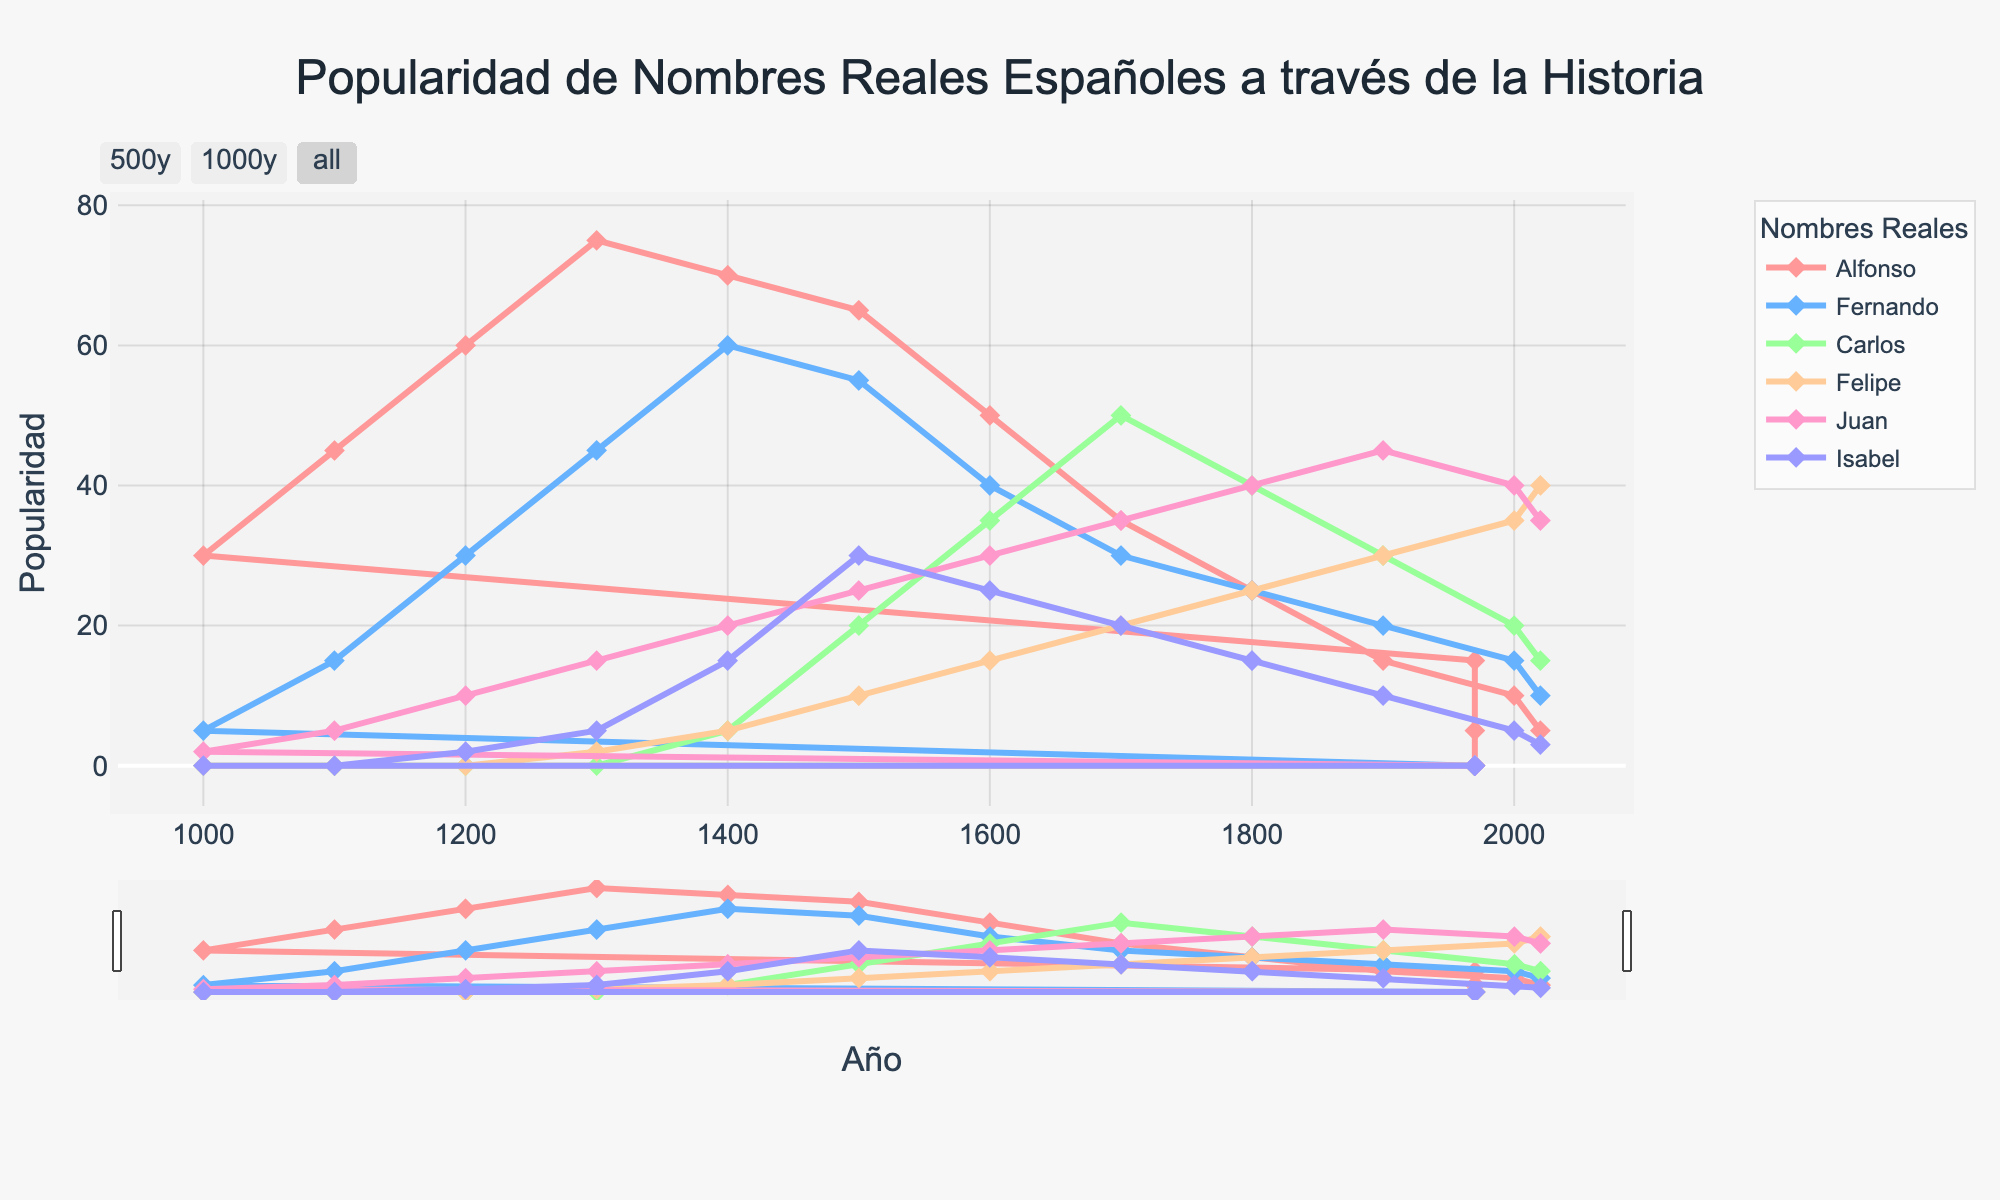Which name has the highest popularity in the year 1300? To determine this, we look at the data points for each name in the year 1300. Alfonso is at 75, Fernando is 45, Carlos is 0, Felipe is 2, Juan is 15, and Isabel is 5. Alfonso has the highest value.
Answer: Alfonso Which name shows a consistent decline in popularity after the 1300s? By examining the trend lines, Alfonso peaks at 1300 with a value of 75 and then declines consistently over the following years.
Answer: Alfonso Between the 1500s and 2000s, which name increases its popularity the most? We need to compare the values of each name in 1500 and 2000. Alfonso goes from 65 to 10 (-55), Fernando from 55 to 15 (-40), Carlos from 20 to 20 (0), Felipe from 10 to 35 (+25), Juan from 25 to 40 (+15), and Isabel from 30 to 5 (-25). Felipe shows the greatest increase of 25.
Answer: Felipe Which names had equal popularity at any point in history? By visually comparing the graphs, we see that in 2020, Juan and Felipe both have a popularity of 35.
Answer: Juan and Felipe How does the popularity of Isabel in the 1200s compare to her popularity in the 1400s? In the 1200s, Isabel has a popularity of 2, while in the 1400s, it increases to 15. Hence, her popularity increased by 13 points.
Answer: 13 points increase Which name had the most significant fall in popularity from one century to the next? Examining the plot lines, Alfonso had the most significant drop from the 1300s (75) to the 1400s (70), a drop of 45 points.
Answer: Alfonso What is the range of popularity for Fernando across the data? The maximum value for Fernando is at 60, and the minimum is at 0. The range is therefore 60 - 0 = 60.
Answer: 60 Which names were popular before the 1000s and which were not? By looking at the values before the year 1000, only Alfonso shows popularity with non-zero values, while Fernando, Carlos, Felipe, Juan, and Isabel have zero values.
Answer: Alfonso was popular; others were not Compare the total popularity of the top two names in the 1700s. In the 1700s, the top two names are Carlos (50) and Juan (35). Summing their values, 50 + 35 = 85.
Answer: 85 What was the average popularity of all names in the year 2000? Sum the popularity values for all names in 2000: 10 (Alfonso) + 15 (Fernando) + 20 (Carlos) + 35 (Felipe) + 40 (Juan) + 5 (Isabel) = 125. Divide by 6 (number of names): 125 / 6 ≈ 20.83.
Answer: 20.83 